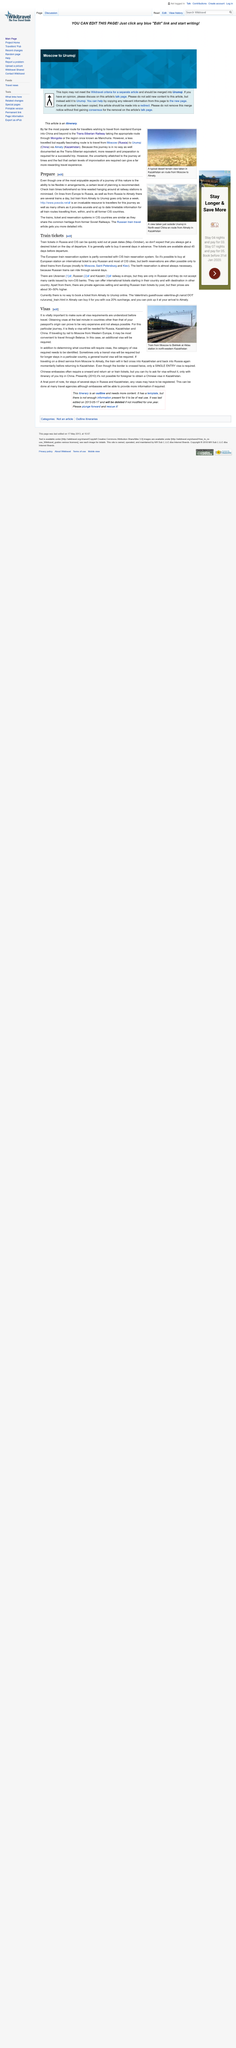Highlight a few significant elements in this photo. Trains in CIS countries are similar because they share a Soviet heritage. It is recommended that individuals planning a trip to CIS countries carefully check the train times to ensure a smooth and efficient journey. Trains depart from Almaty, Kazakhstan to Urumqi, China twice a week, with a frequency of once every seven days. 